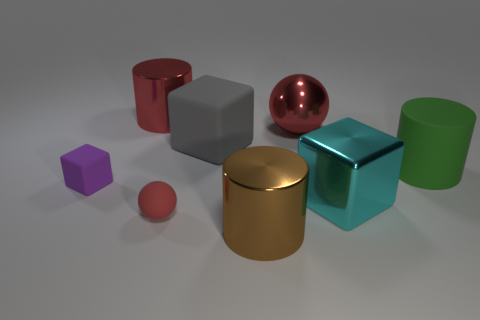What is the shape of the metallic thing that is the same color as the large ball?
Ensure brevity in your answer.  Cylinder. There is a green cylinder; is it the same size as the shiny cylinder behind the red matte thing?
Offer a terse response. Yes. What color is the metal cylinder right of the shiny object that is behind the red sphere that is behind the green matte object?
Offer a terse response. Brown. The large matte cylinder has what color?
Offer a terse response. Green. Are there more shiny cubes that are on the left side of the big red cylinder than big red metallic spheres that are in front of the tiny purple cube?
Give a very brief answer. No. Is the shape of the red matte object the same as the red metal thing on the right side of the gray matte object?
Your answer should be compact. Yes. There is a block to the left of the small red object; is its size the same as the red sphere in front of the large gray cube?
Offer a very short reply. Yes. Are there any green cylinders that are in front of the big block in front of the rubber cube behind the big green thing?
Provide a succinct answer. No. Is the number of red cylinders in front of the brown metal cylinder less than the number of large matte cylinders that are left of the large cyan cube?
Make the answer very short. No. What is the shape of the other small object that is made of the same material as the purple thing?
Your answer should be compact. Sphere. 